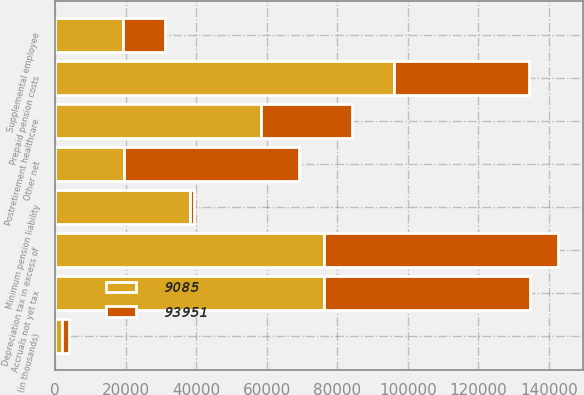Convert chart to OTSL. <chart><loc_0><loc_0><loc_500><loc_500><stacked_bar_chart><ecel><fcel>(in thousands)<fcel>Accruals not yet tax<fcel>Postretirement healthcare<fcel>Supplemental employee<fcel>Minimum pension liability<fcel>Other net<fcel>Depreciation tax in excess of<fcel>Prepaid pension costs<nl><fcel>93951<fcel>2005<fcel>58436<fcel>25862<fcel>11834<fcel>1205<fcel>49659<fcel>66273<fcel>38230<nl><fcel>9085<fcel>2004<fcel>76192<fcel>58455<fcel>19387<fcel>38230<fcel>19535<fcel>76385<fcel>96163<nl></chart> 